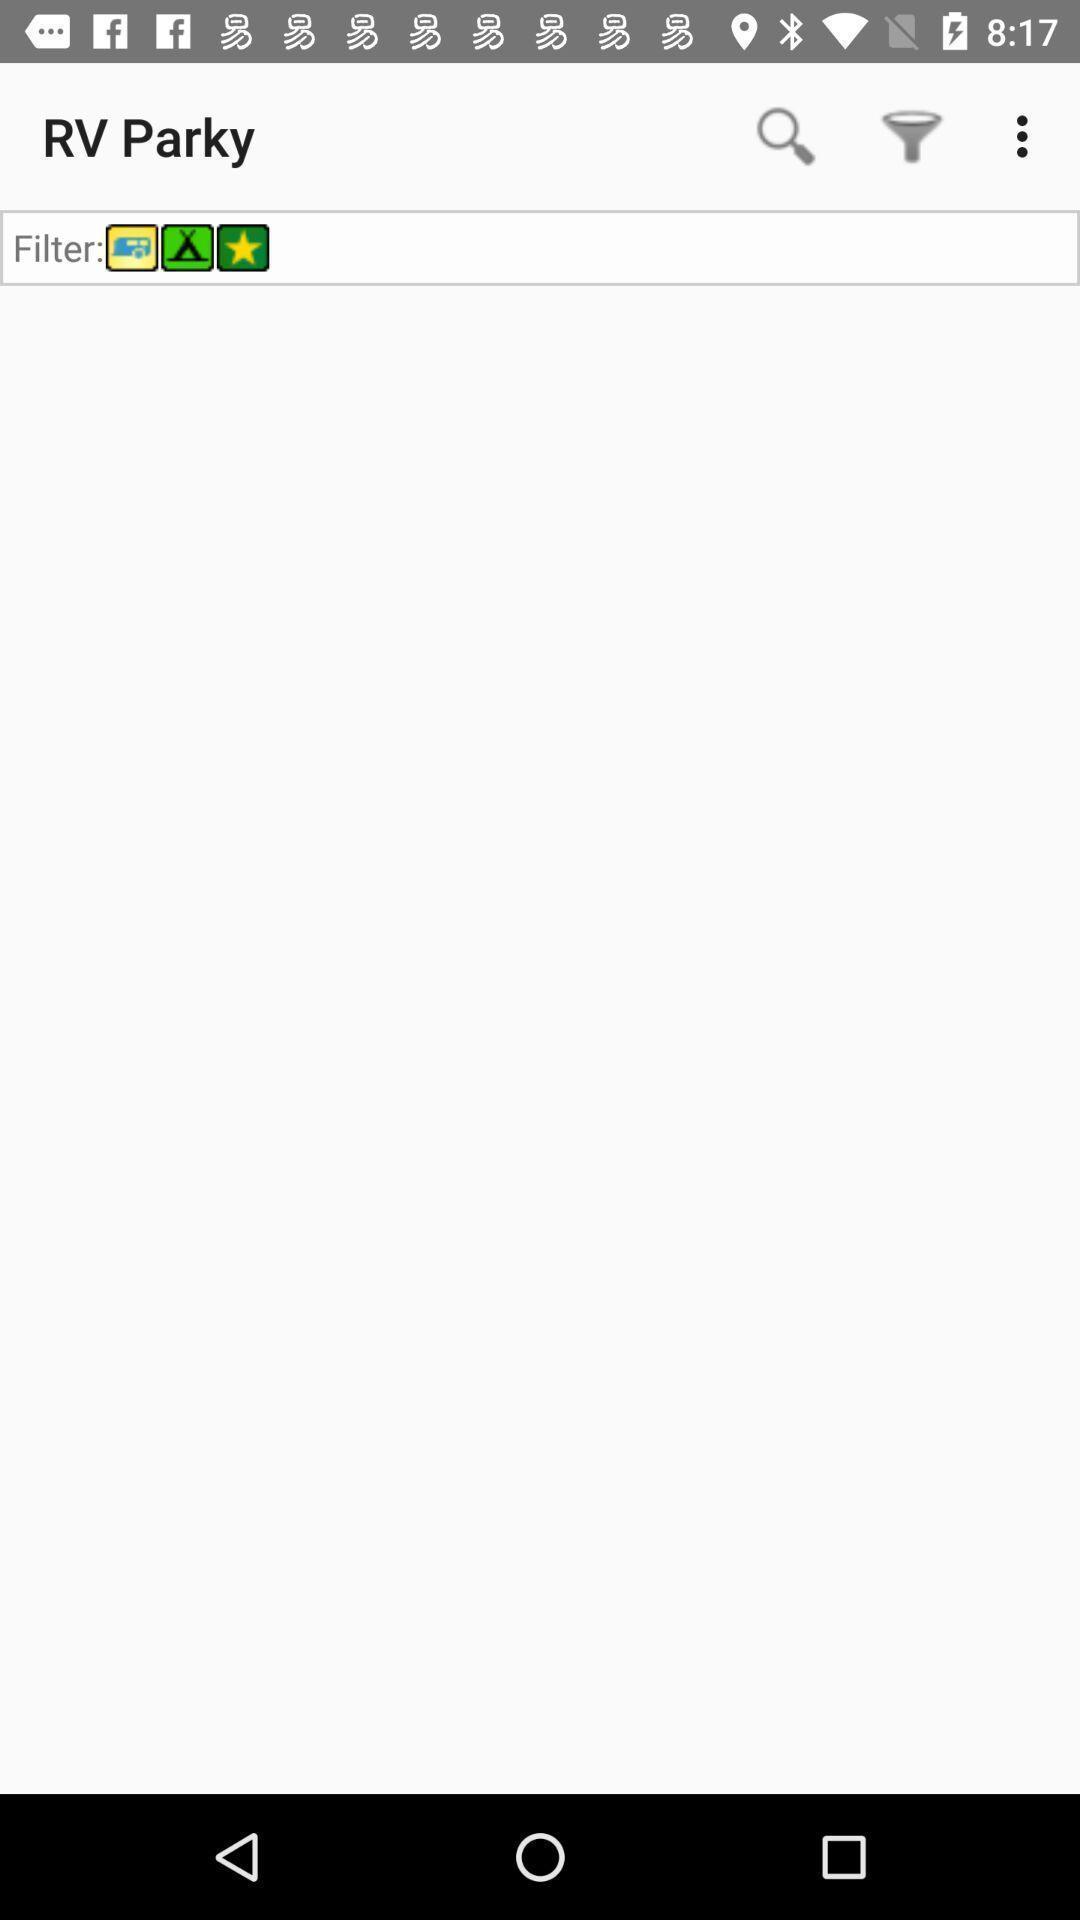What details can you identify in this image? Search page. 